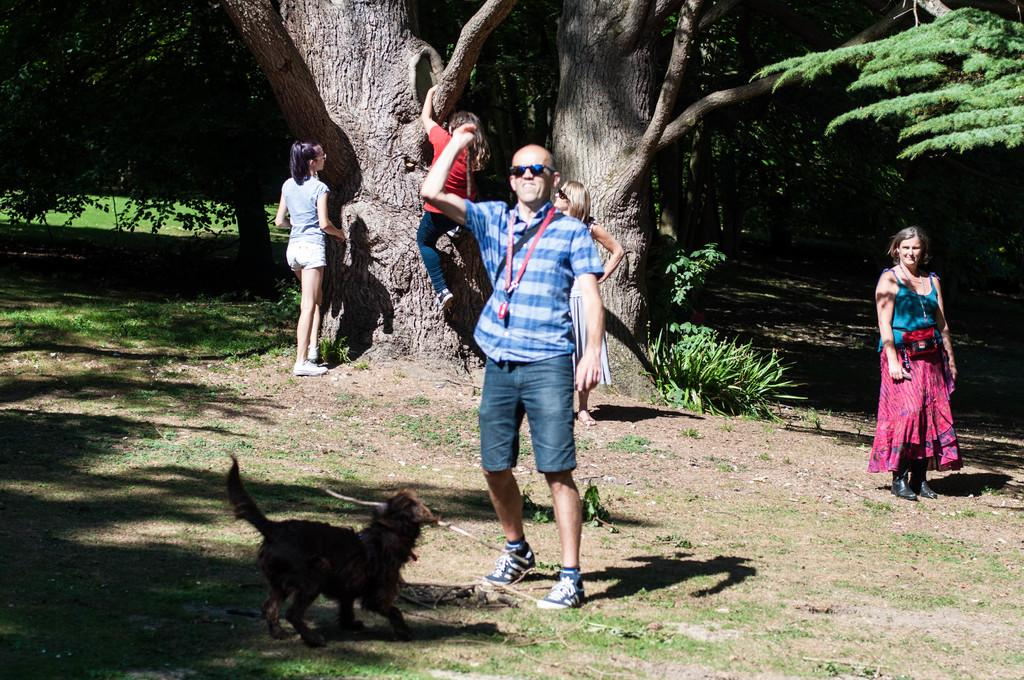What type of surface can be seen in the image? There is ground visible in the image. What is the presence of people in the image suggest? There are people standing in the image, which suggests that there might be an activity or gathering taking place. What type of animal is in the image? There is a dog in the image. What type of vegetation is present in the image? There are plants and trees in the image. What is a person doing in the image? A person is climbing a tree in the image. What type of holiday is being celebrated in the image? There is no indication of a holiday being celebrated in the image. What color is the sock on the dog's paw in the image? There is no sock present on the dog's paw in the image. 